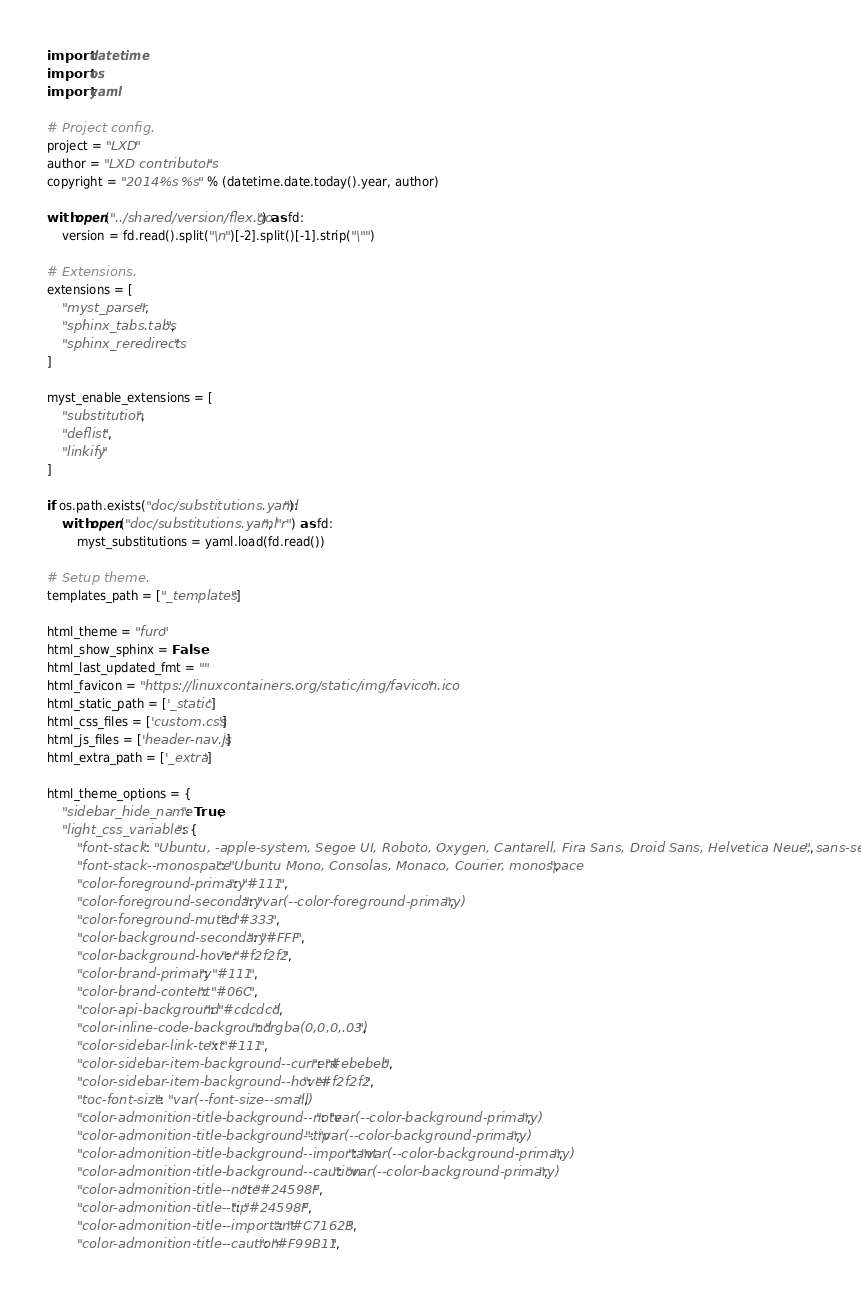Convert code to text. <code><loc_0><loc_0><loc_500><loc_500><_Python_>import datetime
import os
import yaml

# Project config.
project = "LXD"
author = "LXD contributors"
copyright = "2014-%s %s" % (datetime.date.today().year, author)

with open("../shared/version/flex.go") as fd:
    version = fd.read().split("\n")[-2].split()[-1].strip("\"")

# Extensions.
extensions = [
    "myst_parser",
    "sphinx_tabs.tabs",
    "sphinx_reredirects"
]

myst_enable_extensions = [
    "substitution",
    "deflist",
    "linkify"
]

if os.path.exists("doc/substitutions.yaml"):
    with open("doc/substitutions.yaml", "r") as fd:
        myst_substitutions = yaml.load(fd.read())

# Setup theme.
templates_path = ["_templates"]

html_theme = "furo"
html_show_sphinx = False
html_last_updated_fmt = ""
html_favicon = "https://linuxcontainers.org/static/img/favicon.ico"
html_static_path = ['_static']
html_css_files = ['custom.css']
html_js_files = ['header-nav.js']
html_extra_path = ['_extra']

html_theme_options = {
    "sidebar_hide_name": True,
    "light_css_variables": {
        "font-stack": "Ubuntu, -apple-system, Segoe UI, Roboto, Oxygen, Cantarell, Fira Sans, Droid Sans, Helvetica Neue, sans-serif",
        "font-stack--monospace": "Ubuntu Mono, Consolas, Monaco, Courier, monospace",
        "color-foreground-primary": "#111",
        "color-foreground-secondary": "var(--color-foreground-primary)",
        "color-foreground-muted": "#333",
        "color-background-secondary": "#FFF",
        "color-background-hover": "#f2f2f2",
        "color-brand-primary": "#111",
        "color-brand-content": "#06C",
        "color-api-background": "#cdcdcd",
        "color-inline-code-background": "rgba(0,0,0,.03)",
        "color-sidebar-link-text": "#111",
        "color-sidebar-item-background--current": "#ebebeb",
        "color-sidebar-item-background--hover": "#f2f2f2",
        "toc-font-size": "var(--font-size--small)",
        "color-admonition-title-background--note": "var(--color-background-primary)",
        "color-admonition-title-background--tip": "var(--color-background-primary)",
        "color-admonition-title-background--important": "var(--color-background-primary)",
        "color-admonition-title-background--caution": "var(--color-background-primary)",
        "color-admonition-title--note": "#24598F",
        "color-admonition-title--tip": "#24598F",
        "color-admonition-title--important": "#C7162B",
        "color-admonition-title--caution": "#F99B11",</code> 